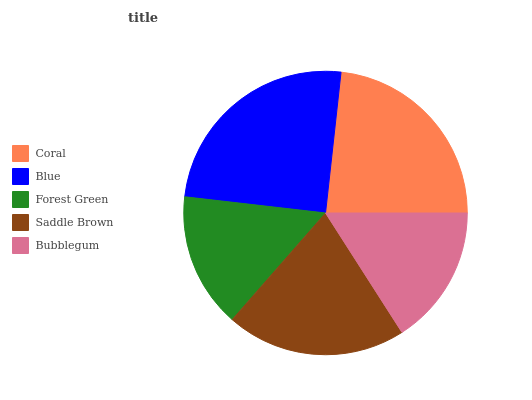Is Forest Green the minimum?
Answer yes or no. Yes. Is Blue the maximum?
Answer yes or no. Yes. Is Blue the minimum?
Answer yes or no. No. Is Forest Green the maximum?
Answer yes or no. No. Is Blue greater than Forest Green?
Answer yes or no. Yes. Is Forest Green less than Blue?
Answer yes or no. Yes. Is Forest Green greater than Blue?
Answer yes or no. No. Is Blue less than Forest Green?
Answer yes or no. No. Is Saddle Brown the high median?
Answer yes or no. Yes. Is Saddle Brown the low median?
Answer yes or no. Yes. Is Coral the high median?
Answer yes or no. No. Is Coral the low median?
Answer yes or no. No. 